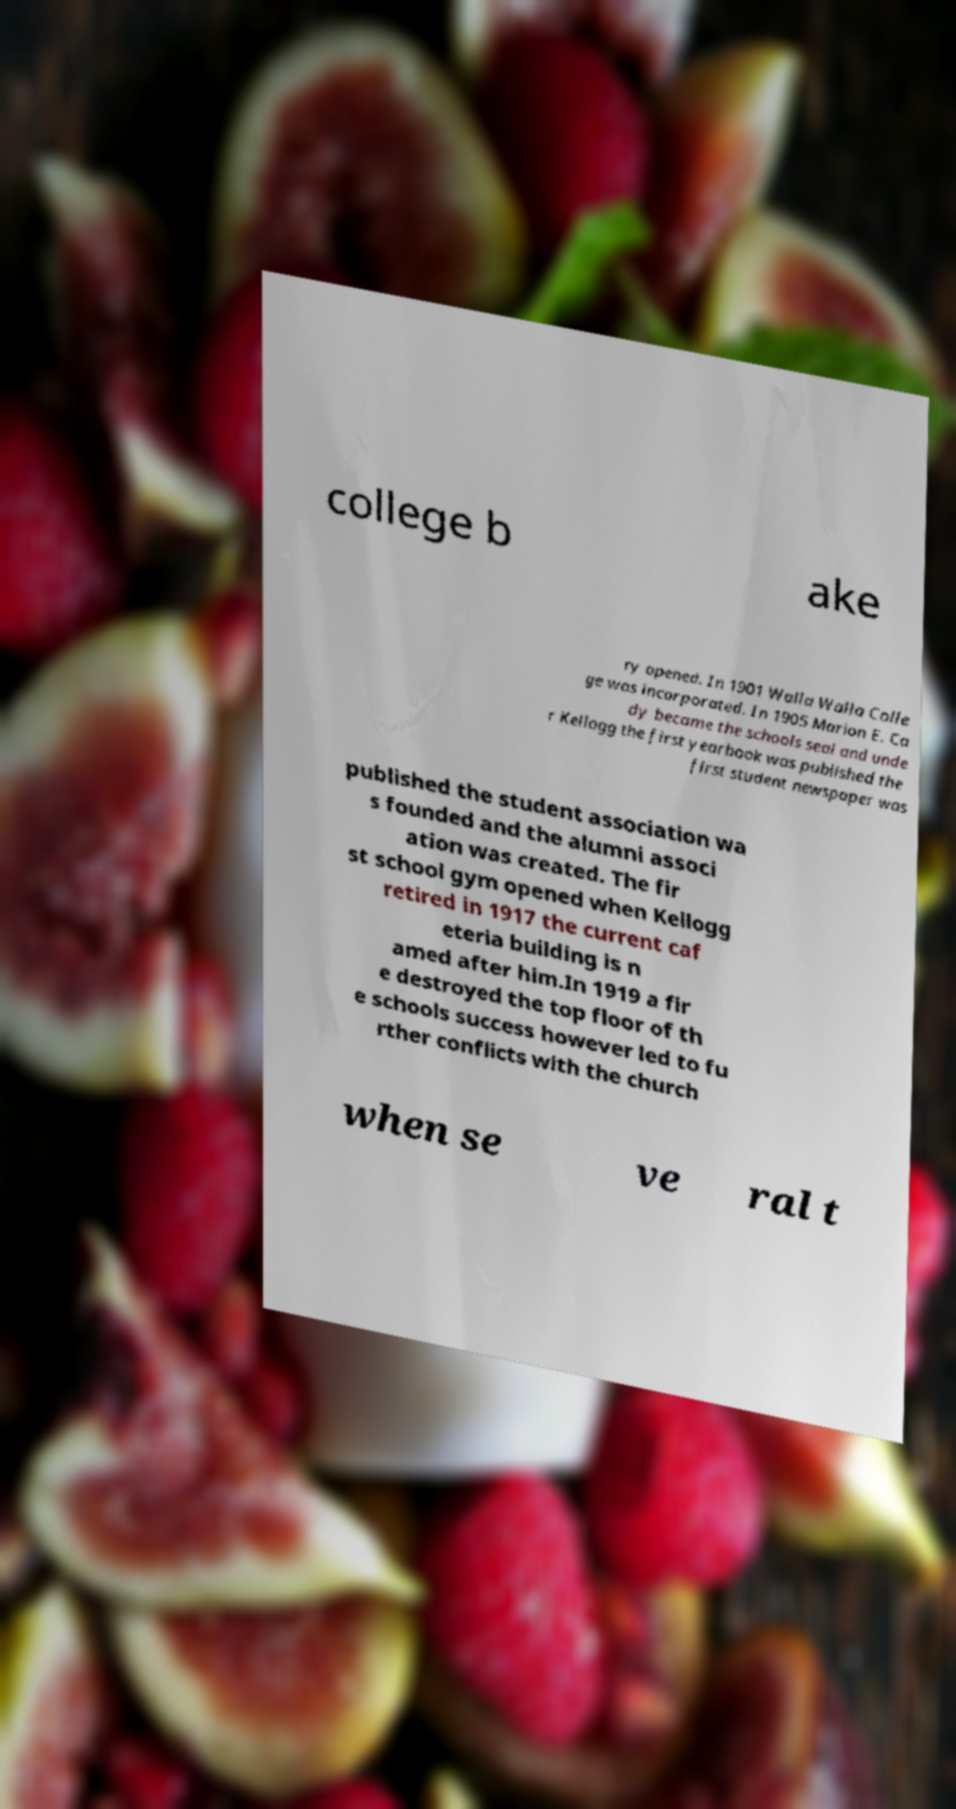Can you accurately transcribe the text from the provided image for me? college b ake ry opened. In 1901 Walla Walla Colle ge was incorporated. In 1905 Marion E. Ca dy became the schools seal and unde r Kellogg the first yearbook was published the first student newspaper was published the student association wa s founded and the alumni associ ation was created. The fir st school gym opened when Kellogg retired in 1917 the current caf eteria building is n amed after him.In 1919 a fir e destroyed the top floor of th e schools success however led to fu rther conflicts with the church when se ve ral t 